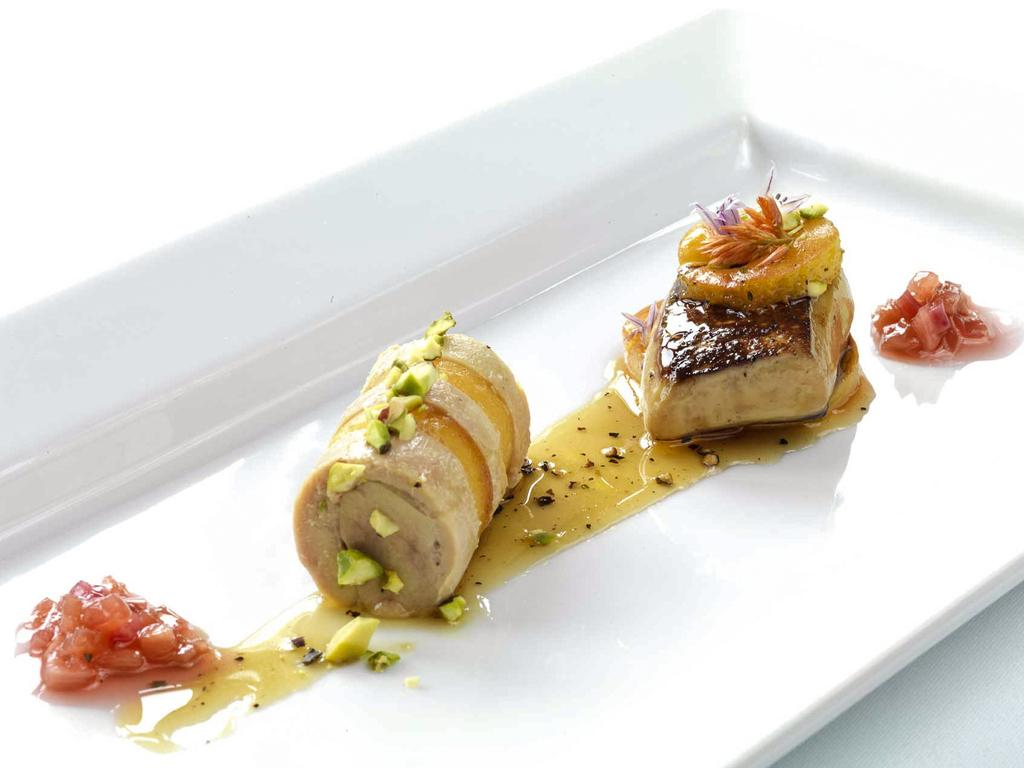What is the main subject of the image? The main subject of the image is food. What can be observed about the plate the food is on? The plate is white in color. What colors can be seen in the food? The food has cream, red, and brown colors. How many corn cobs are visible on the edge of the plate in the image? There is no corn present in the image, so it is not possible to determine the number of corn cobs. 